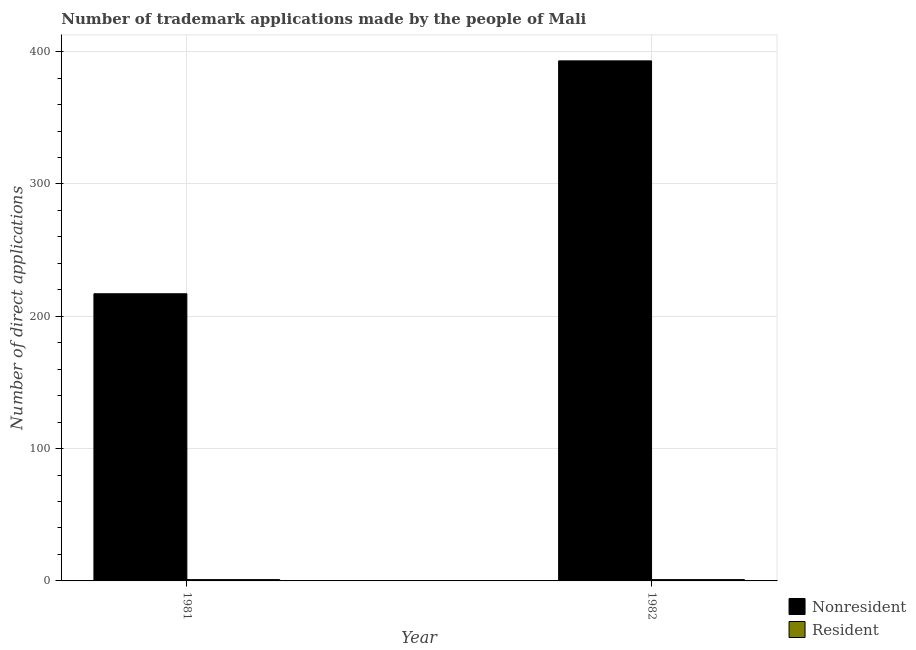How many different coloured bars are there?
Keep it short and to the point. 2. Are the number of bars per tick equal to the number of legend labels?
Your response must be concise. Yes. Are the number of bars on each tick of the X-axis equal?
Give a very brief answer. Yes. How many bars are there on the 2nd tick from the right?
Provide a short and direct response. 2. What is the label of the 2nd group of bars from the left?
Make the answer very short. 1982. In how many cases, is the number of bars for a given year not equal to the number of legend labels?
Provide a short and direct response. 0. What is the number of trademark applications made by residents in 1981?
Your answer should be compact. 1. Across all years, what is the maximum number of trademark applications made by residents?
Offer a terse response. 1. Across all years, what is the minimum number of trademark applications made by residents?
Ensure brevity in your answer.  1. In which year was the number of trademark applications made by residents minimum?
Provide a succinct answer. 1981. What is the total number of trademark applications made by non residents in the graph?
Provide a succinct answer. 610. What is the difference between the number of trademark applications made by non residents in 1981 and that in 1982?
Offer a terse response. -176. What is the difference between the number of trademark applications made by residents in 1981 and the number of trademark applications made by non residents in 1982?
Your response must be concise. 0. In how many years, is the number of trademark applications made by non residents greater than 300?
Your answer should be very brief. 1. What does the 1st bar from the left in 1981 represents?
Your answer should be very brief. Nonresident. What does the 1st bar from the right in 1981 represents?
Your answer should be very brief. Resident. How many bars are there?
Your response must be concise. 4. Are all the bars in the graph horizontal?
Offer a terse response. No. How many years are there in the graph?
Offer a very short reply. 2. What is the difference between two consecutive major ticks on the Y-axis?
Give a very brief answer. 100. Does the graph contain grids?
Give a very brief answer. Yes. Where does the legend appear in the graph?
Provide a succinct answer. Bottom right. How many legend labels are there?
Keep it short and to the point. 2. What is the title of the graph?
Ensure brevity in your answer.  Number of trademark applications made by the people of Mali. What is the label or title of the X-axis?
Your answer should be very brief. Year. What is the label or title of the Y-axis?
Offer a very short reply. Number of direct applications. What is the Number of direct applications of Nonresident in 1981?
Your answer should be compact. 217. What is the Number of direct applications in Nonresident in 1982?
Ensure brevity in your answer.  393. What is the Number of direct applications of Resident in 1982?
Make the answer very short. 1. Across all years, what is the maximum Number of direct applications in Nonresident?
Provide a succinct answer. 393. Across all years, what is the maximum Number of direct applications in Resident?
Give a very brief answer. 1. Across all years, what is the minimum Number of direct applications in Nonresident?
Provide a succinct answer. 217. Across all years, what is the minimum Number of direct applications in Resident?
Your answer should be very brief. 1. What is the total Number of direct applications of Nonresident in the graph?
Provide a succinct answer. 610. What is the total Number of direct applications of Resident in the graph?
Provide a succinct answer. 2. What is the difference between the Number of direct applications of Nonresident in 1981 and that in 1982?
Keep it short and to the point. -176. What is the difference between the Number of direct applications in Nonresident in 1981 and the Number of direct applications in Resident in 1982?
Provide a succinct answer. 216. What is the average Number of direct applications in Nonresident per year?
Your answer should be compact. 305. What is the average Number of direct applications in Resident per year?
Your response must be concise. 1. In the year 1981, what is the difference between the Number of direct applications in Nonresident and Number of direct applications in Resident?
Ensure brevity in your answer.  216. In the year 1982, what is the difference between the Number of direct applications of Nonresident and Number of direct applications of Resident?
Offer a terse response. 392. What is the ratio of the Number of direct applications in Nonresident in 1981 to that in 1982?
Keep it short and to the point. 0.55. What is the ratio of the Number of direct applications of Resident in 1981 to that in 1982?
Provide a short and direct response. 1. What is the difference between the highest and the second highest Number of direct applications of Nonresident?
Offer a very short reply. 176. What is the difference between the highest and the lowest Number of direct applications in Nonresident?
Offer a very short reply. 176. 